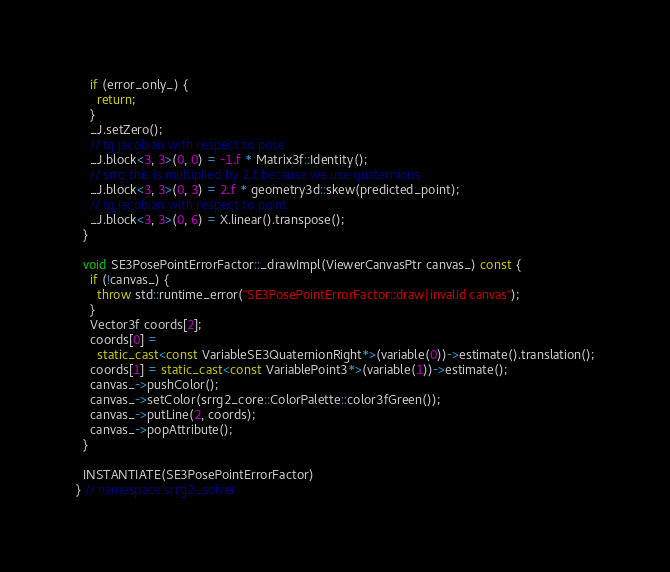Convert code to text. <code><loc_0><loc_0><loc_500><loc_500><_C++_>    if (error_only_) {
      return;
    }
    _J.setZero();
    // tg jacobian with respect to pose
    _J.block<3, 3>(0, 0) = -1.f * Matrix3f::Identity();
    // srrg this is multiplied by 2.f because we use quaternions
    _J.block<3, 3>(0, 3) = 2.f * geometry3d::skew(predicted_point);
    // tg jacobian with respect to point
    _J.block<3, 3>(0, 6) = X.linear().transpose();
  }

  void SE3PosePointErrorFactor::_drawImpl(ViewerCanvasPtr canvas_) const {
    if (!canvas_) {
      throw std::runtime_error("SE3PosePointErrorFactor::draw|invalid canvas");
    }
    Vector3f coords[2];
    coords[0] =
      static_cast<const VariableSE3QuaternionRight*>(variable(0))->estimate().translation();
    coords[1] = static_cast<const VariablePoint3*>(variable(1))->estimate();
    canvas_->pushColor();
    canvas_->setColor(srrg2_core::ColorPalette::color3fGreen());
    canvas_->putLine(2, coords);
    canvas_->popAttribute();
  }

  INSTANTIATE(SE3PosePointErrorFactor)
} // namespace srrg2_solver
</code> 